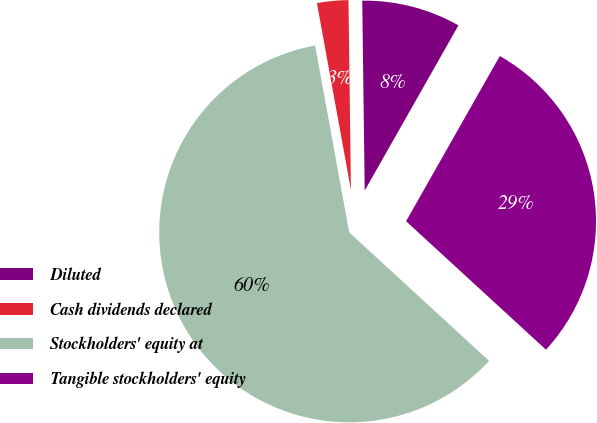Convert chart to OTSL. <chart><loc_0><loc_0><loc_500><loc_500><pie_chart><fcel>Diluted<fcel>Cash dividends declared<fcel>Stockholders' equity at<fcel>Tangible stockholders' equity<nl><fcel>8.42%<fcel>2.66%<fcel>60.31%<fcel>28.61%<nl></chart> 